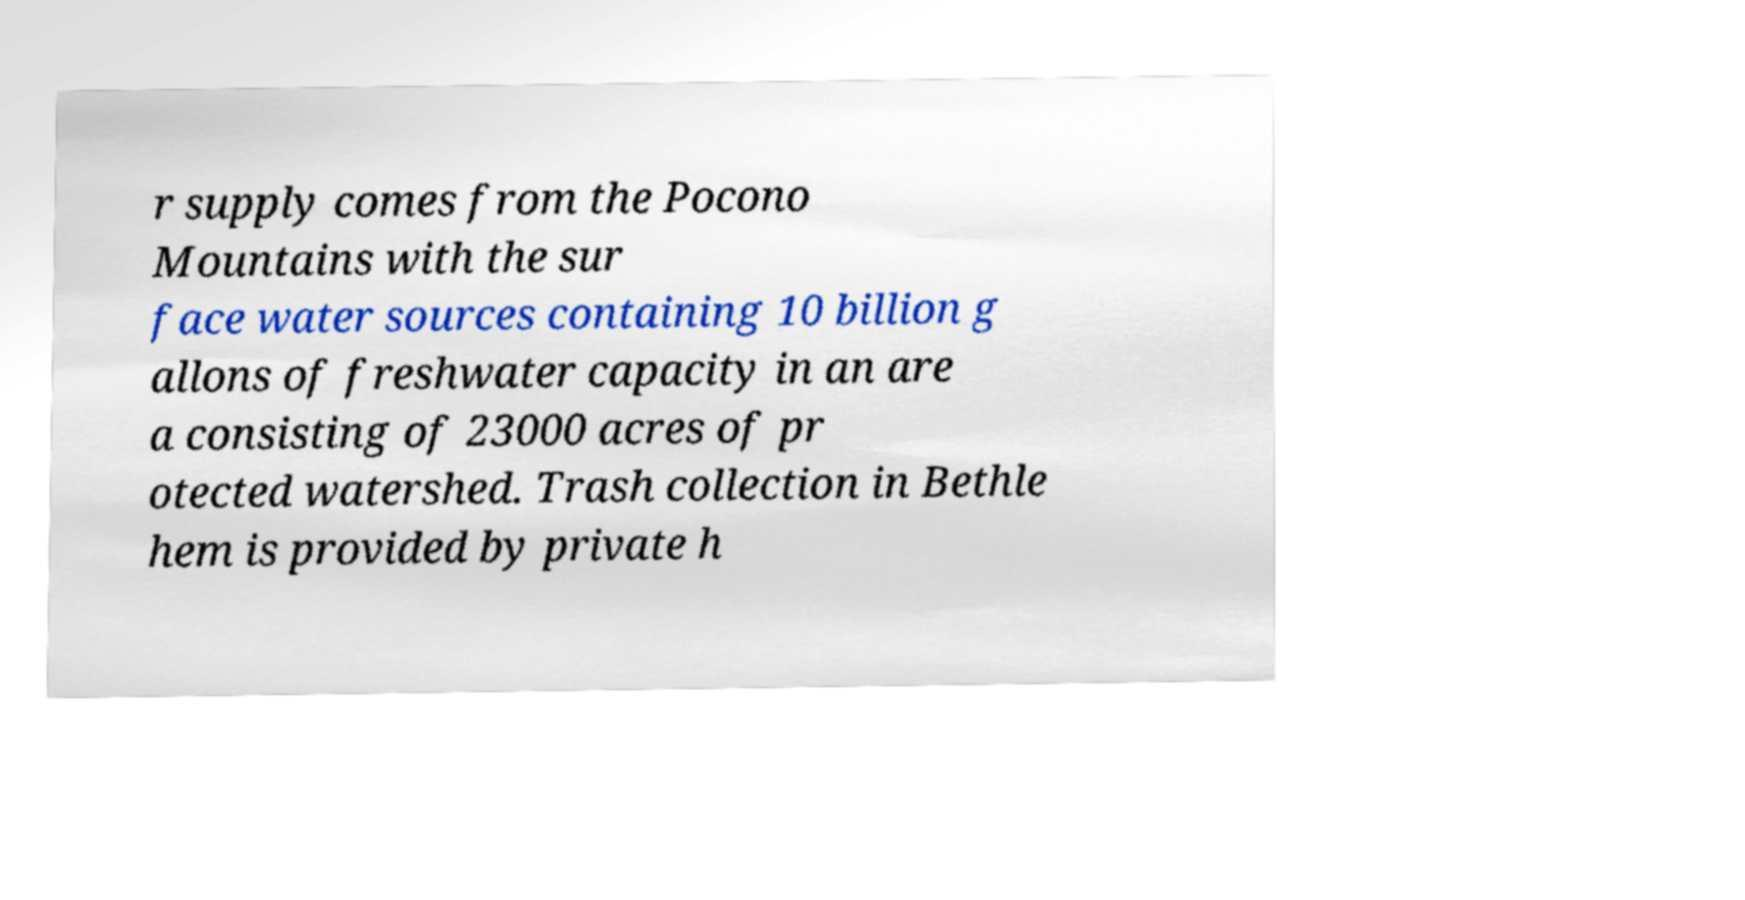Can you read and provide the text displayed in the image?This photo seems to have some interesting text. Can you extract and type it out for me? r supply comes from the Pocono Mountains with the sur face water sources containing 10 billion g allons of freshwater capacity in an are a consisting of 23000 acres of pr otected watershed. Trash collection in Bethle hem is provided by private h 